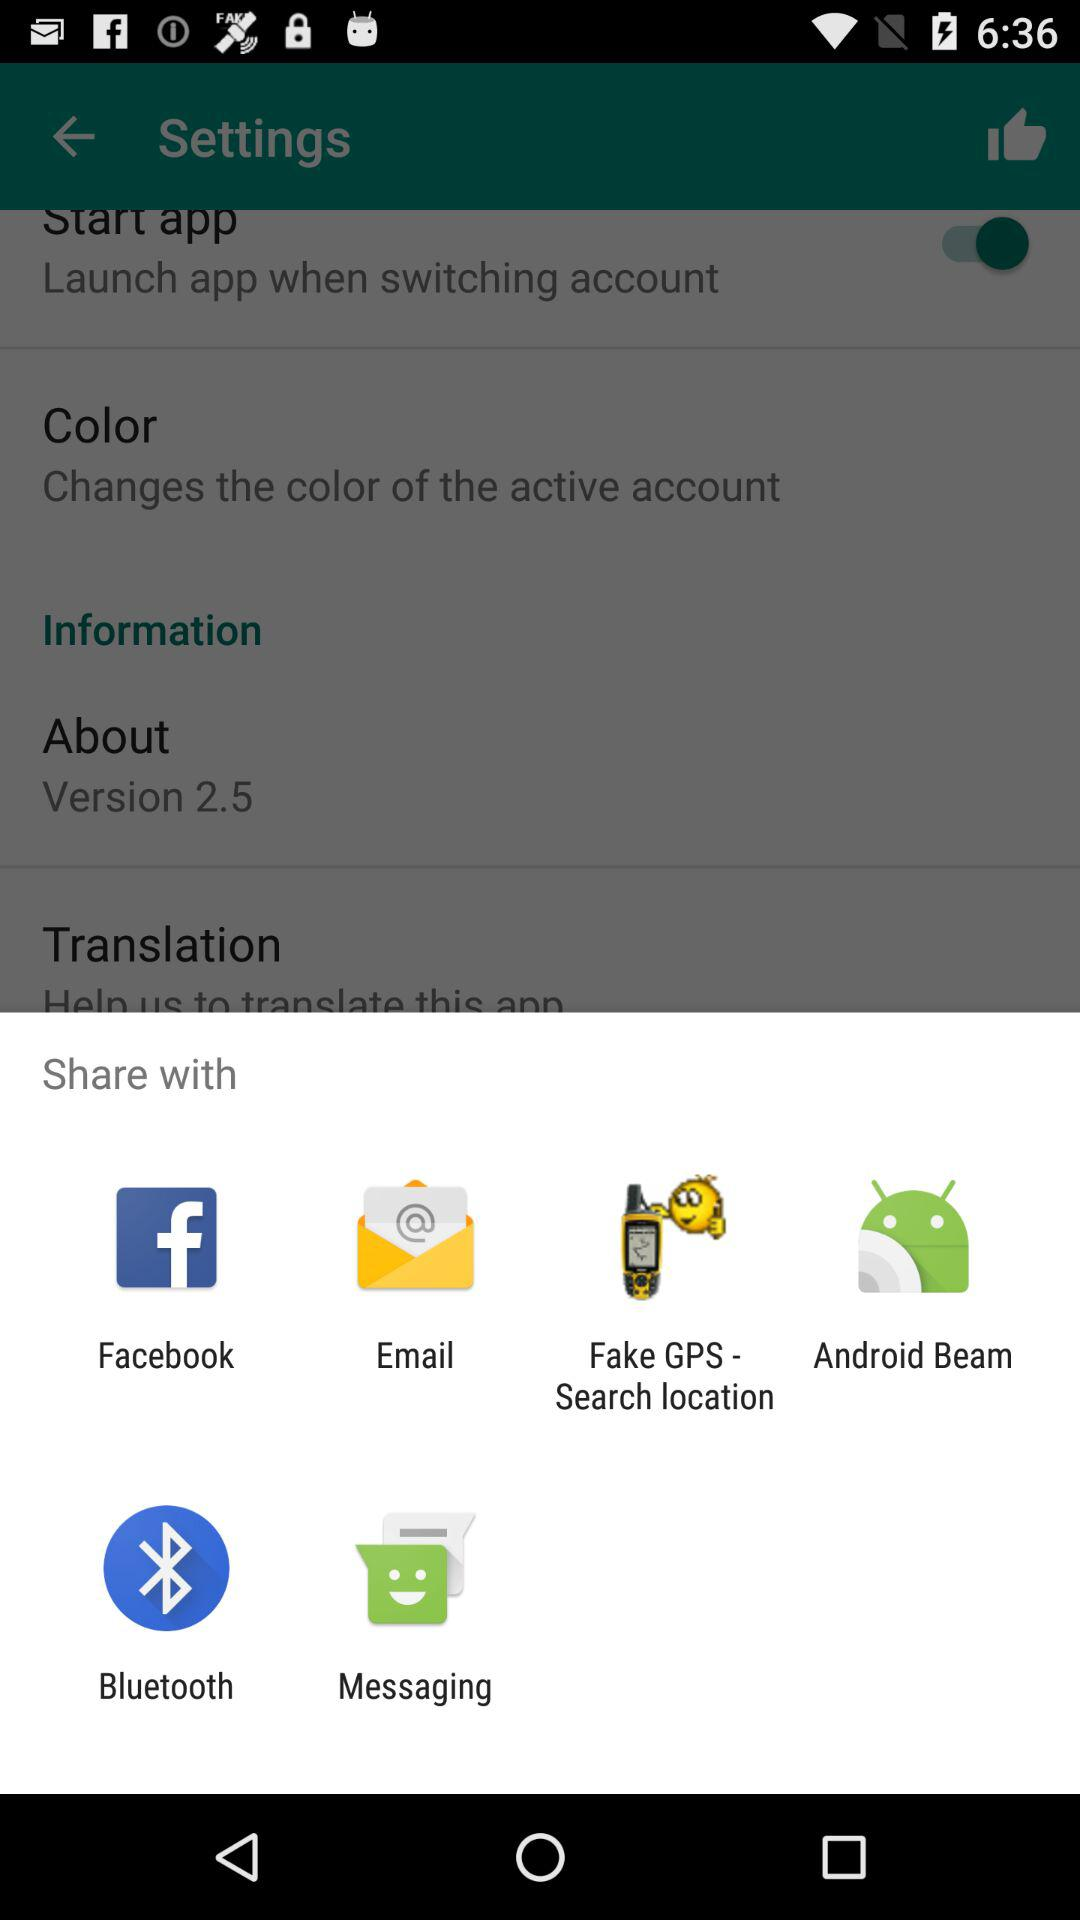What is the version? The version is 2.5. 